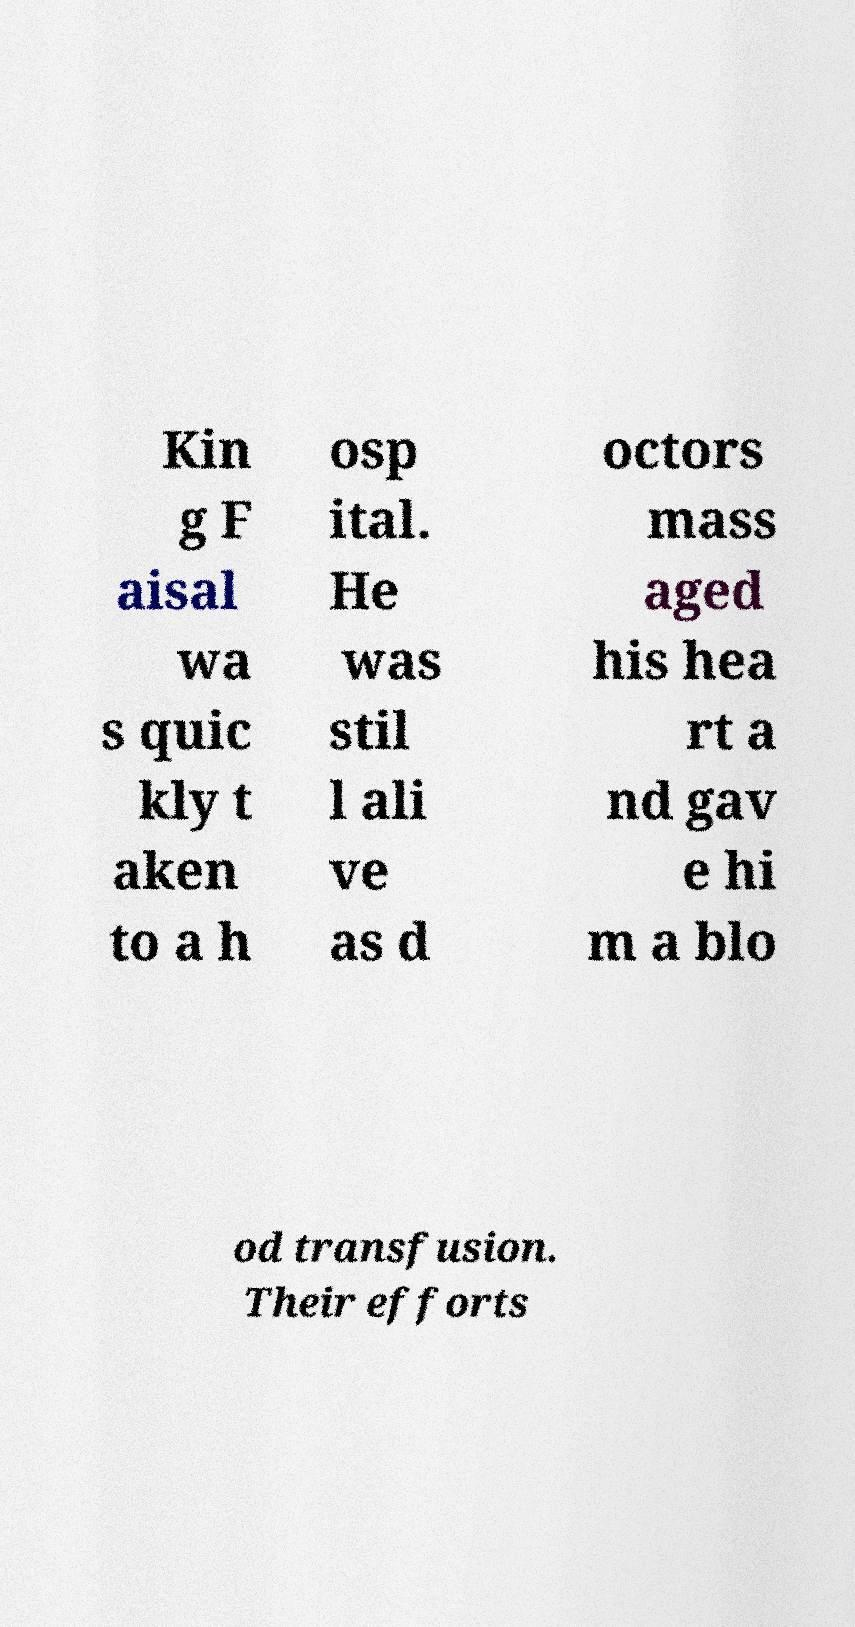For documentation purposes, I need the text within this image transcribed. Could you provide that? Kin g F aisal wa s quic kly t aken to a h osp ital. He was stil l ali ve as d octors mass aged his hea rt a nd gav e hi m a blo od transfusion. Their efforts 